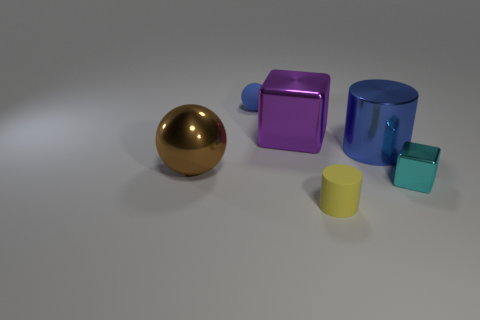What number of other cylinders have the same size as the matte cylinder?
Your response must be concise. 0. There is a blue thing that is in front of the tiny thing that is behind the big purple thing; what is its shape?
Give a very brief answer. Cylinder. Is the number of green matte balls less than the number of purple metallic blocks?
Provide a short and direct response. Yes. There is a cylinder that is behind the tiny yellow matte cylinder; what is its color?
Provide a short and direct response. Blue. What material is the large object that is right of the blue matte object and on the left side of the tiny rubber cylinder?
Provide a short and direct response. Metal. There is a tiny cyan thing that is the same material as the big cube; what shape is it?
Keep it short and to the point. Cube. There is a rubber thing that is in front of the large purple block; how many big shiny blocks are in front of it?
Offer a terse response. 0. How many large things are right of the big ball and in front of the big purple thing?
Make the answer very short. 1. How many other things are there of the same material as the large blue cylinder?
Provide a short and direct response. 3. What is the color of the rubber object in front of the blue thing that is in front of the purple metal cube?
Make the answer very short. Yellow. 